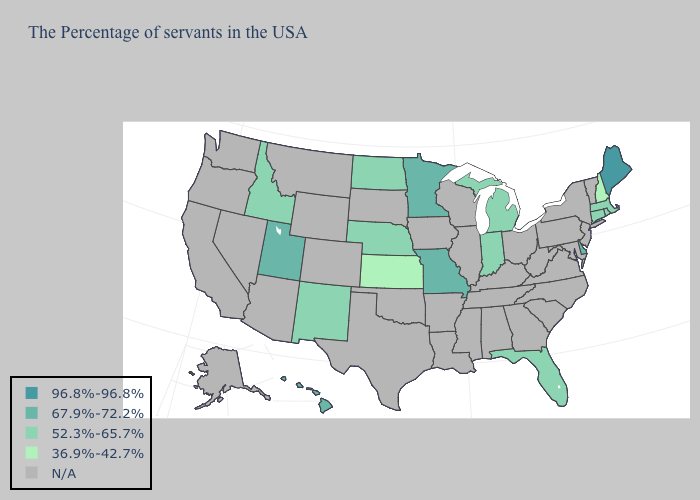Which states have the highest value in the USA?
Concise answer only. Maine. Which states have the lowest value in the USA?
Short answer required. New Hampshire, Kansas. Name the states that have a value in the range 67.9%-72.2%?
Concise answer only. Delaware, Missouri, Minnesota, Utah, Hawaii. Does the map have missing data?
Keep it brief. Yes. Does the first symbol in the legend represent the smallest category?
Answer briefly. No. Which states have the highest value in the USA?
Keep it brief. Maine. Name the states that have a value in the range 52.3%-65.7%?
Answer briefly. Massachusetts, Rhode Island, Connecticut, Florida, Michigan, Indiana, Nebraska, North Dakota, New Mexico, Idaho. Does Delaware have the lowest value in the South?
Write a very short answer. No. Name the states that have a value in the range 52.3%-65.7%?
Give a very brief answer. Massachusetts, Rhode Island, Connecticut, Florida, Michigan, Indiana, Nebraska, North Dakota, New Mexico, Idaho. Does Florida have the lowest value in the South?
Write a very short answer. Yes. Name the states that have a value in the range 36.9%-42.7%?
Give a very brief answer. New Hampshire, Kansas. 